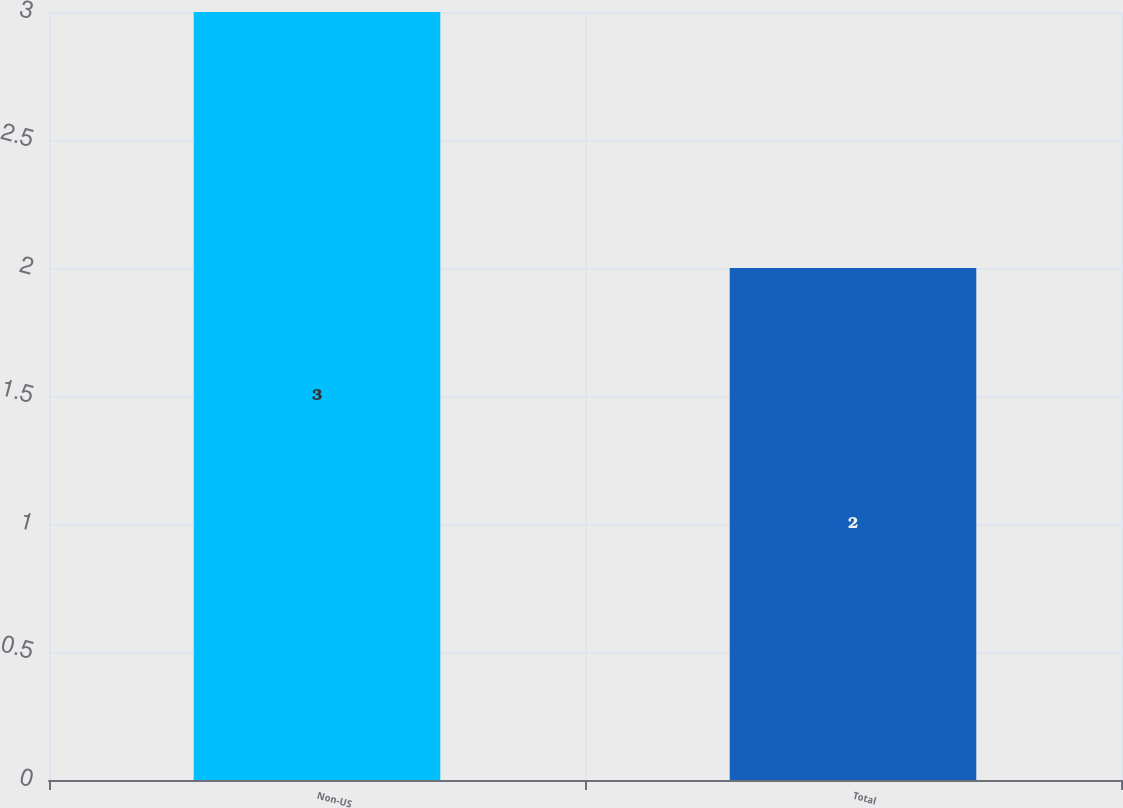<chart> <loc_0><loc_0><loc_500><loc_500><bar_chart><fcel>Non-US<fcel>Total<nl><fcel>3<fcel>2<nl></chart> 